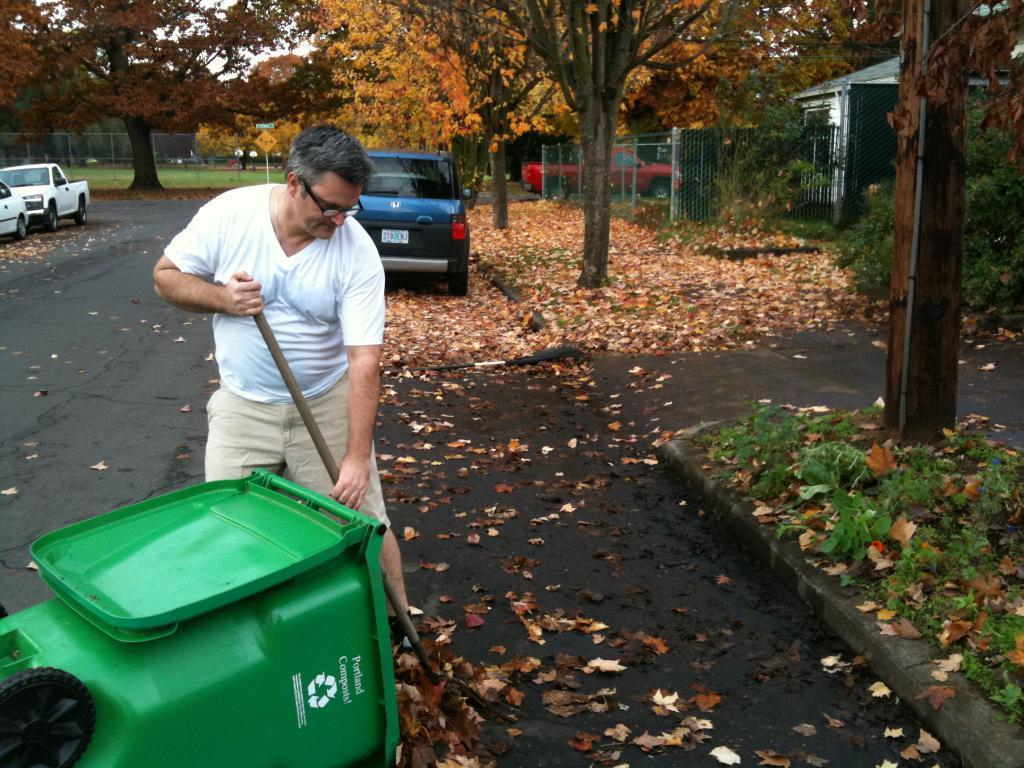Describe this image in one or two sentences. In this picture we can see a man, he wore spectacles and he is cleaning the road, in front of him we can find a dustbin, beside to him we can see few trees, a pole and fence, in the background we can find few vehicles and a house. 